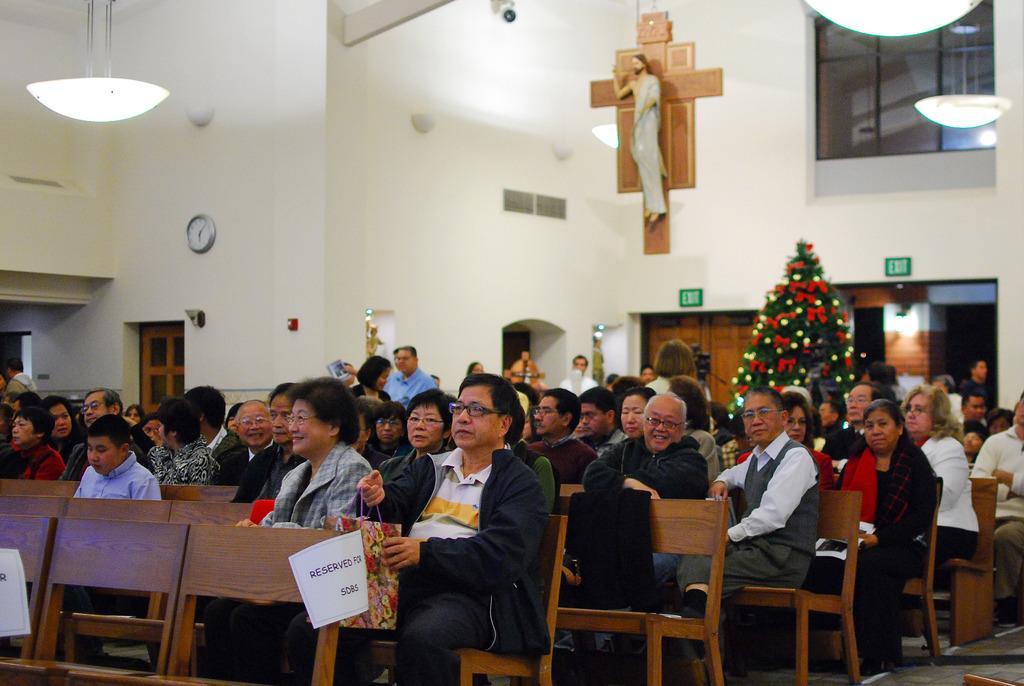How would you summarize this image in a sentence or two? In this image there are so many people sitting on their chairs, a few of them is holding bags in their hand, behind them there is a Christmas tree and statues. In the background there is a wall and there is a clock, lamp and a statue of Jesus Christ is hanging on the wall and there is a door. 